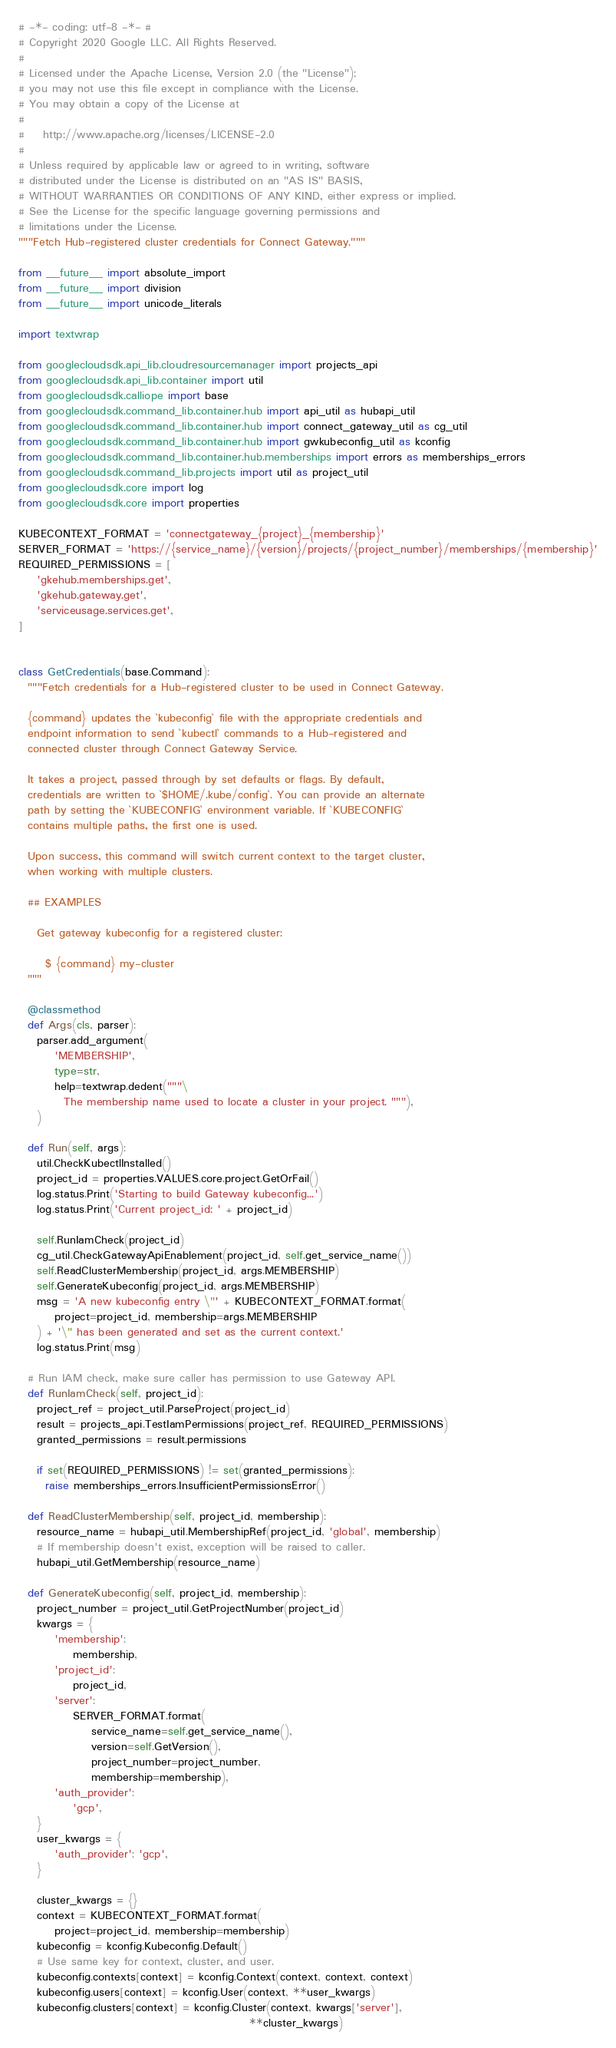<code> <loc_0><loc_0><loc_500><loc_500><_Python_># -*- coding: utf-8 -*- #
# Copyright 2020 Google LLC. All Rights Reserved.
#
# Licensed under the Apache License, Version 2.0 (the "License");
# you may not use this file except in compliance with the License.
# You may obtain a copy of the License at
#
#    http://www.apache.org/licenses/LICENSE-2.0
#
# Unless required by applicable law or agreed to in writing, software
# distributed under the License is distributed on an "AS IS" BASIS,
# WITHOUT WARRANTIES OR CONDITIONS OF ANY KIND, either express or implied.
# See the License for the specific language governing permissions and
# limitations under the License.
"""Fetch Hub-registered cluster credentials for Connect Gateway."""

from __future__ import absolute_import
from __future__ import division
from __future__ import unicode_literals

import textwrap

from googlecloudsdk.api_lib.cloudresourcemanager import projects_api
from googlecloudsdk.api_lib.container import util
from googlecloudsdk.calliope import base
from googlecloudsdk.command_lib.container.hub import api_util as hubapi_util
from googlecloudsdk.command_lib.container.hub import connect_gateway_util as cg_util
from googlecloudsdk.command_lib.container.hub import gwkubeconfig_util as kconfig
from googlecloudsdk.command_lib.container.hub.memberships import errors as memberships_errors
from googlecloudsdk.command_lib.projects import util as project_util
from googlecloudsdk.core import log
from googlecloudsdk.core import properties

KUBECONTEXT_FORMAT = 'connectgateway_{project}_{membership}'
SERVER_FORMAT = 'https://{service_name}/{version}/projects/{project_number}/memberships/{membership}'
REQUIRED_PERMISSIONS = [
    'gkehub.memberships.get',
    'gkehub.gateway.get',
    'serviceusage.services.get',
]


class GetCredentials(base.Command):
  """Fetch credentials for a Hub-registered cluster to be used in Connect Gateway.

  {command} updates the `kubeconfig` file with the appropriate credentials and
  endpoint information to send `kubectl` commands to a Hub-registered and
  connected cluster through Connect Gateway Service.

  It takes a project, passed through by set defaults or flags. By default,
  credentials are written to `$HOME/.kube/config`. You can provide an alternate
  path by setting the `KUBECONFIG` environment variable. If `KUBECONFIG`
  contains multiple paths, the first one is used.

  Upon success, this command will switch current context to the target cluster,
  when working with multiple clusters.

  ## EXAMPLES

    Get gateway kubeconfig for a registered cluster:

      $ {command} my-cluster
  """

  @classmethod
  def Args(cls, parser):
    parser.add_argument(
        'MEMBERSHIP',
        type=str,
        help=textwrap.dedent("""\
          The membership name used to locate a cluster in your project. """),
    )

  def Run(self, args):
    util.CheckKubectlInstalled()
    project_id = properties.VALUES.core.project.GetOrFail()
    log.status.Print('Starting to build Gateway kubeconfig...')
    log.status.Print('Current project_id: ' + project_id)

    self.RunIamCheck(project_id)
    cg_util.CheckGatewayApiEnablement(project_id, self.get_service_name())
    self.ReadClusterMembership(project_id, args.MEMBERSHIP)
    self.GenerateKubeconfig(project_id, args.MEMBERSHIP)
    msg = 'A new kubeconfig entry \"' + KUBECONTEXT_FORMAT.format(
        project=project_id, membership=args.MEMBERSHIP
    ) + '\" has been generated and set as the current context.'
    log.status.Print(msg)

  # Run IAM check, make sure caller has permission to use Gateway API.
  def RunIamCheck(self, project_id):
    project_ref = project_util.ParseProject(project_id)
    result = projects_api.TestIamPermissions(project_ref, REQUIRED_PERMISSIONS)
    granted_permissions = result.permissions

    if set(REQUIRED_PERMISSIONS) != set(granted_permissions):
      raise memberships_errors.InsufficientPermissionsError()

  def ReadClusterMembership(self, project_id, membership):
    resource_name = hubapi_util.MembershipRef(project_id, 'global', membership)
    # If membership doesn't exist, exception will be raised to caller.
    hubapi_util.GetMembership(resource_name)

  def GenerateKubeconfig(self, project_id, membership):
    project_number = project_util.GetProjectNumber(project_id)
    kwargs = {
        'membership':
            membership,
        'project_id':
            project_id,
        'server':
            SERVER_FORMAT.format(
                service_name=self.get_service_name(),
                version=self.GetVersion(),
                project_number=project_number,
                membership=membership),
        'auth_provider':
            'gcp',
    }
    user_kwargs = {
        'auth_provider': 'gcp',
    }

    cluster_kwargs = {}
    context = KUBECONTEXT_FORMAT.format(
        project=project_id, membership=membership)
    kubeconfig = kconfig.Kubeconfig.Default()
    # Use same key for context, cluster, and user.
    kubeconfig.contexts[context] = kconfig.Context(context, context, context)
    kubeconfig.users[context] = kconfig.User(context, **user_kwargs)
    kubeconfig.clusters[context] = kconfig.Cluster(context, kwargs['server'],
                                                   **cluster_kwargs)</code> 